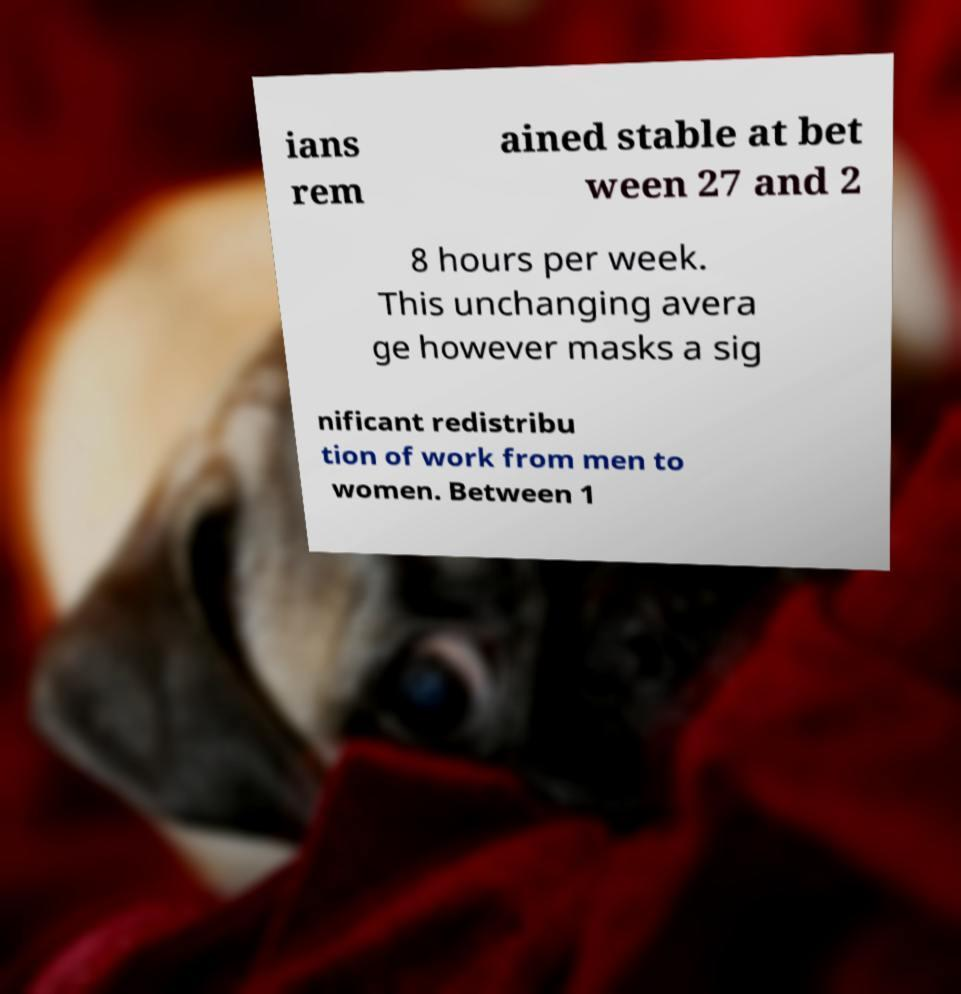I need the written content from this picture converted into text. Can you do that? ians rem ained stable at bet ween 27 and 2 8 hours per week. This unchanging avera ge however masks a sig nificant redistribu tion of work from men to women. Between 1 